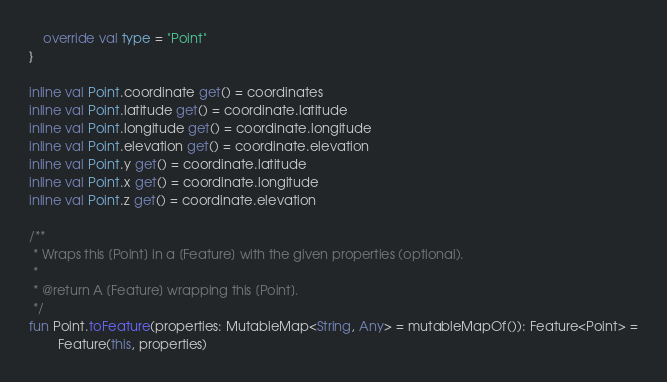Convert code to text. <code><loc_0><loc_0><loc_500><loc_500><_Kotlin_>
    override val type = "Point"
}

inline val Point.coordinate get() = coordinates
inline val Point.latitude get() = coordinate.latitude
inline val Point.longitude get() = coordinate.longitude
inline val Point.elevation get() = coordinate.elevation
inline val Point.y get() = coordinate.latitude
inline val Point.x get() = coordinate.longitude
inline val Point.z get() = coordinate.elevation

/**
 * Wraps this [Point] in a [Feature] with the given properties (optional).
 *
 * @return A [Feature] wrapping this [Point].
 */
fun Point.toFeature(properties: MutableMap<String, Any> = mutableMapOf()): Feature<Point> =
        Feature(this, properties)
</code> 